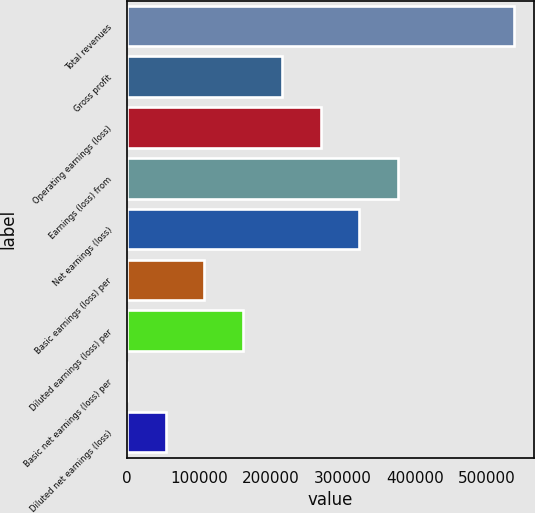Convert chart to OTSL. <chart><loc_0><loc_0><loc_500><loc_500><bar_chart><fcel>Total revenues<fcel>Gross profit<fcel>Operating earnings (loss)<fcel>Earnings (loss) from<fcel>Net earnings (loss)<fcel>Basic earnings (loss) per<fcel>Diluted earnings (loss) per<fcel>Basic net earnings (loss) per<fcel>Diluted net earnings (loss)<nl><fcel>538162<fcel>215265<fcel>269081<fcel>376714<fcel>322897<fcel>107633<fcel>161449<fcel>0.42<fcel>53816.6<nl></chart> 